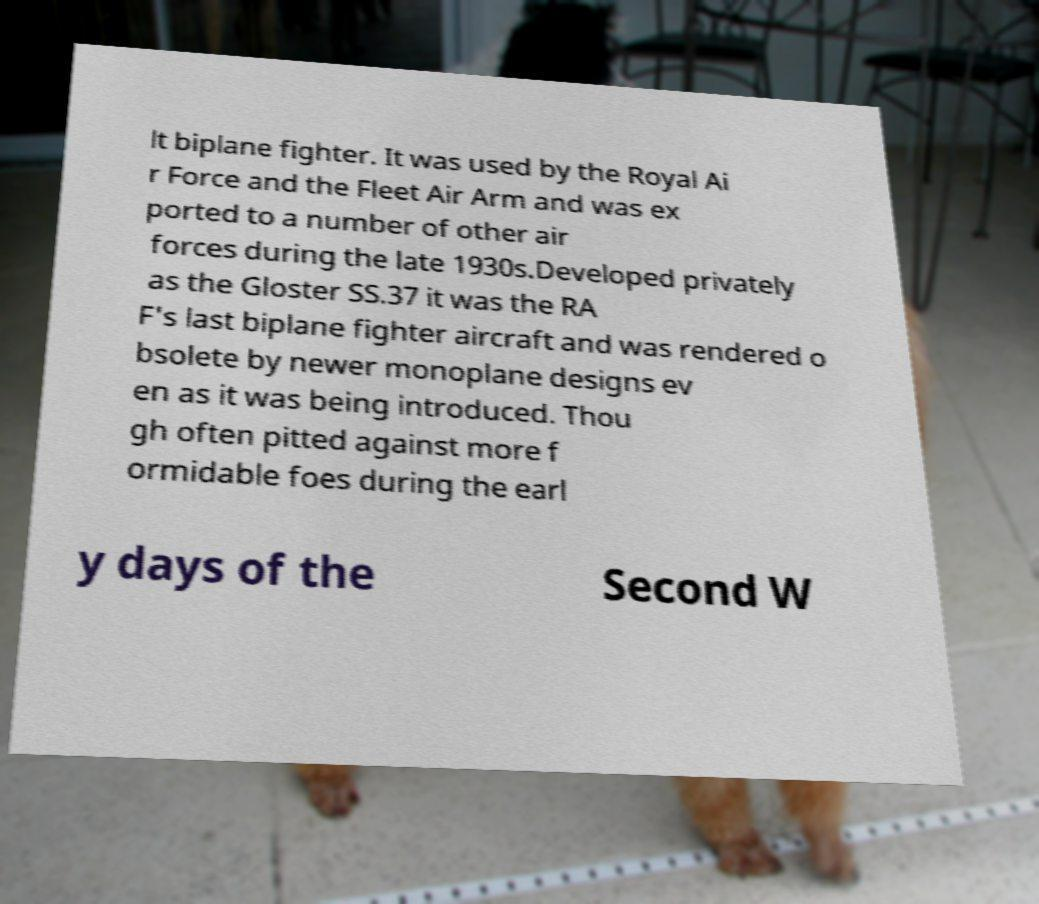For documentation purposes, I need the text within this image transcribed. Could you provide that? lt biplane fighter. It was used by the Royal Ai r Force and the Fleet Air Arm and was ex ported to a number of other air forces during the late 1930s.Developed privately as the Gloster SS.37 it was the RA F's last biplane fighter aircraft and was rendered o bsolete by newer monoplane designs ev en as it was being introduced. Thou gh often pitted against more f ormidable foes during the earl y days of the Second W 